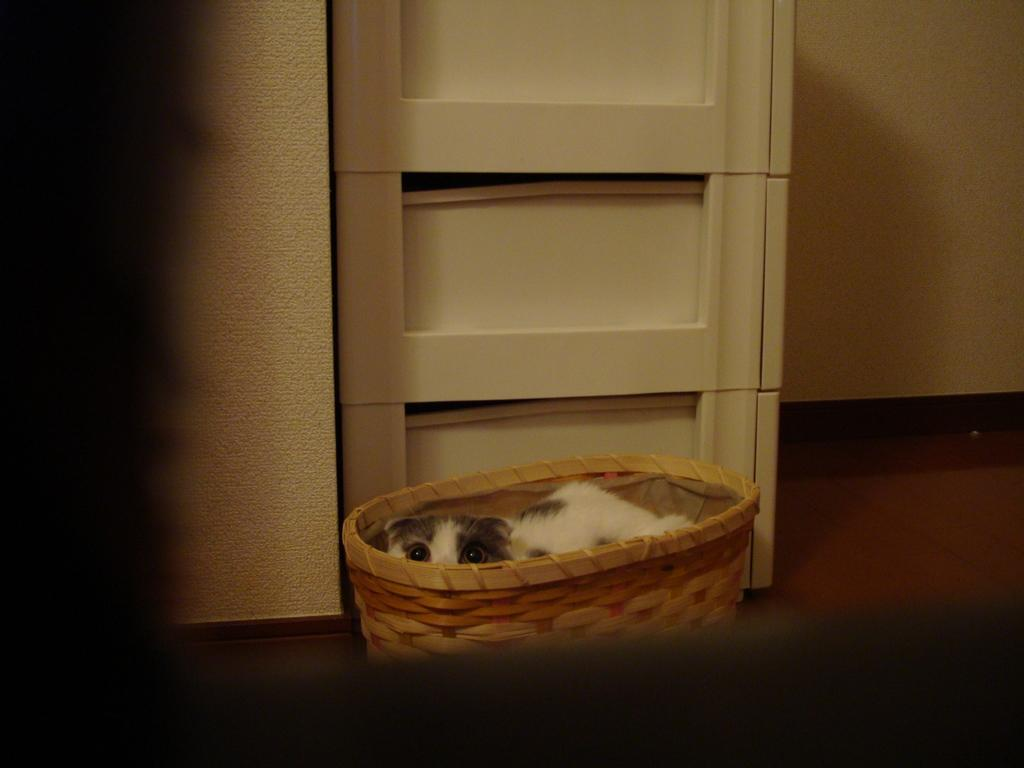What is in the basket that is visible in the image? There is an animal in a basket in the image. Where is the basket located in the image? The basket is placed on the floor. What type of objects can be seen in the image besides the basket? There are white color boxes in the image. What can be seen in the background of the image? There is a wall in the background of the image. How does the kitty adjust the temperature in the image? There is no kitty present in the image, and therefore no adjustment of temperature can be observed. 